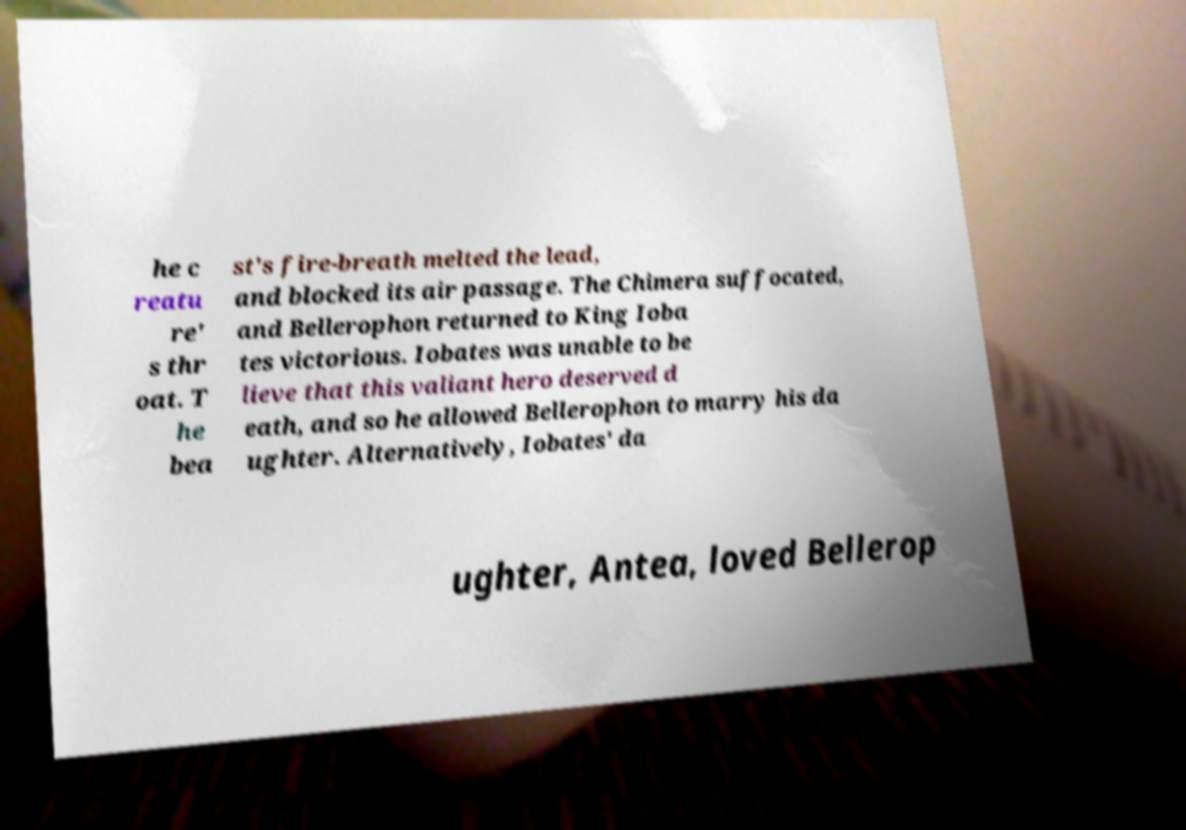For documentation purposes, I need the text within this image transcribed. Could you provide that? he c reatu re' s thr oat. T he bea st's fire-breath melted the lead, and blocked its air passage. The Chimera suffocated, and Bellerophon returned to King Ioba tes victorious. Iobates was unable to be lieve that this valiant hero deserved d eath, and so he allowed Bellerophon to marry his da ughter. Alternatively, Iobates' da ughter, Antea, loved Bellerop 